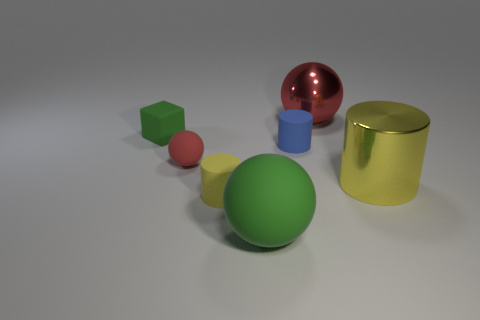Add 1 small brown rubber cubes. How many objects exist? 8 Subtract all tiny red rubber balls. How many balls are left? 2 Subtract all red balls. How many balls are left? 1 Subtract all spheres. How many objects are left? 4 Subtract 2 spheres. How many spheres are left? 1 Subtract all red cylinders. Subtract all green blocks. How many cylinders are left? 3 Subtract all green cylinders. How many cyan spheres are left? 0 Subtract all small yellow spheres. Subtract all small blue things. How many objects are left? 6 Add 2 small matte spheres. How many small matte spheres are left? 3 Add 6 blue rubber cylinders. How many blue rubber cylinders exist? 7 